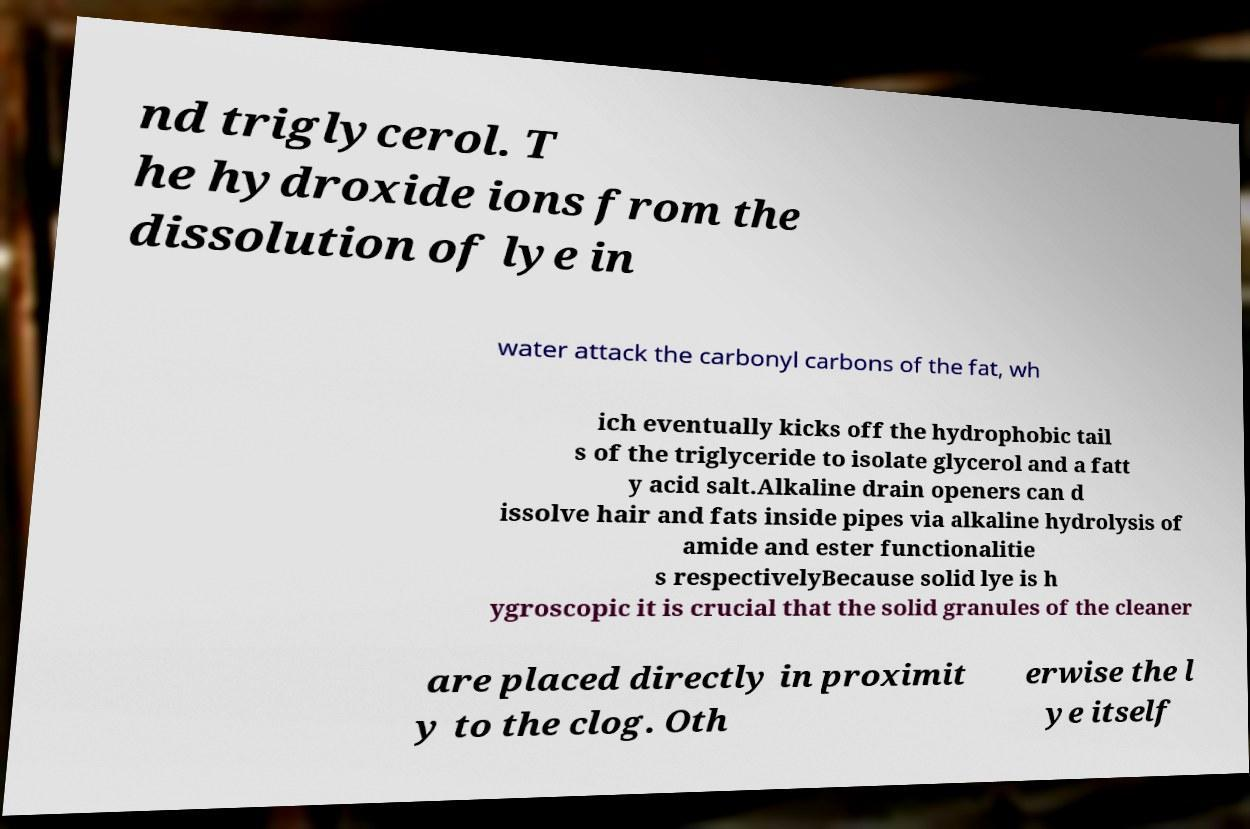I need the written content from this picture converted into text. Can you do that? nd triglycerol. T he hydroxide ions from the dissolution of lye in water attack the carbonyl carbons of the fat, wh ich eventually kicks off the hydrophobic tail s of the triglyceride to isolate glycerol and a fatt y acid salt.Alkaline drain openers can d issolve hair and fats inside pipes via alkaline hydrolysis of amide and ester functionalitie s respectivelyBecause solid lye is h ygroscopic it is crucial that the solid granules of the cleaner are placed directly in proximit y to the clog. Oth erwise the l ye itself 